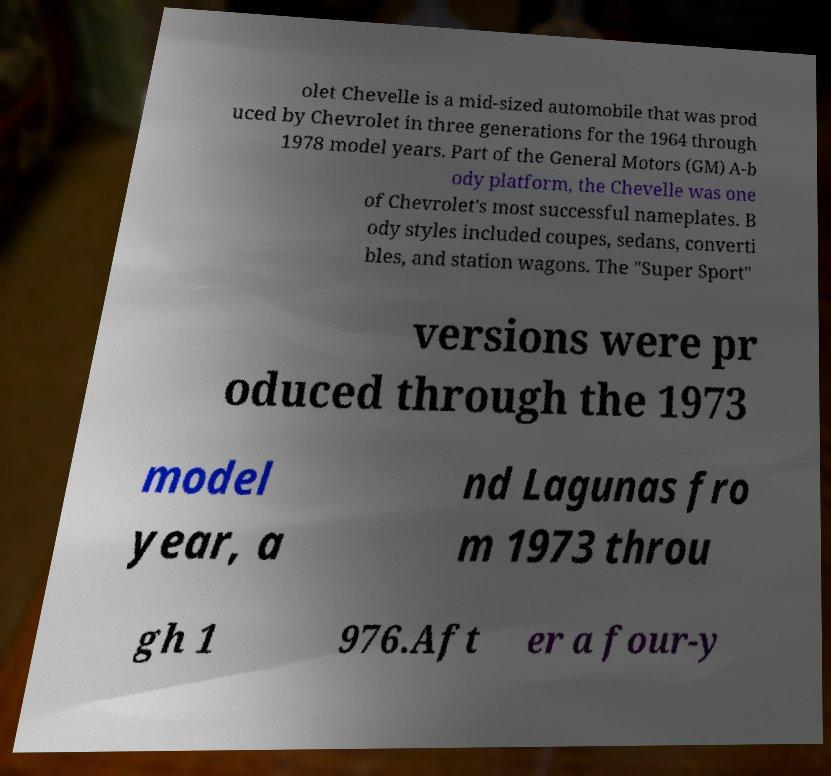For documentation purposes, I need the text within this image transcribed. Could you provide that? olet Chevelle is a mid-sized automobile that was prod uced by Chevrolet in three generations for the 1964 through 1978 model years. Part of the General Motors (GM) A-b ody platform, the Chevelle was one of Chevrolet's most successful nameplates. B ody styles included coupes, sedans, converti bles, and station wagons. The "Super Sport" versions were pr oduced through the 1973 model year, a nd Lagunas fro m 1973 throu gh 1 976.Aft er a four-y 